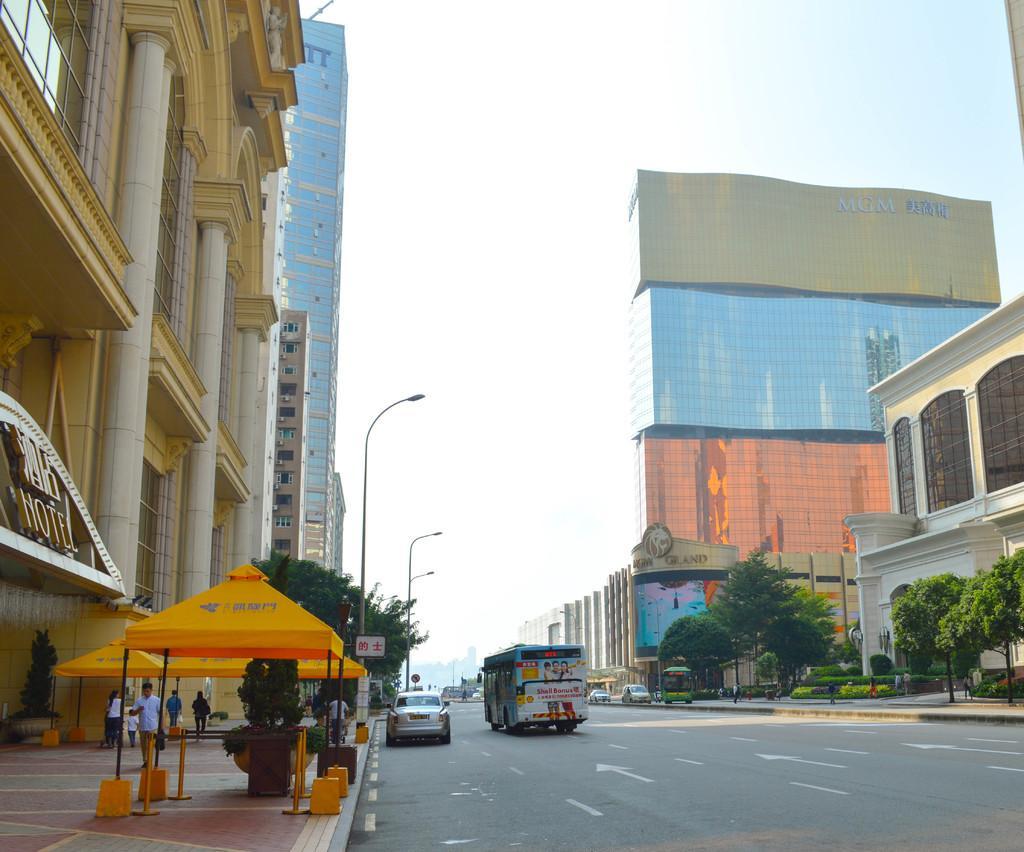In one or two sentences, can you explain what this image depicts? In this image we can see some buildings with windows, pillars and a signboard. We can also see some tents, trees, a sign board, street poles and a group of people standing on the footpath. We can also see a group of vehicles on the road and the sky which looks cloudy. 